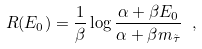Convert formula to latex. <formula><loc_0><loc_0><loc_500><loc_500>R ( E _ { 0 } ) = \frac { 1 } { \beta } \log \frac { \alpha + \beta E _ { 0 } } { \alpha + \beta m _ { \tilde { \tau } } } \ ,</formula> 